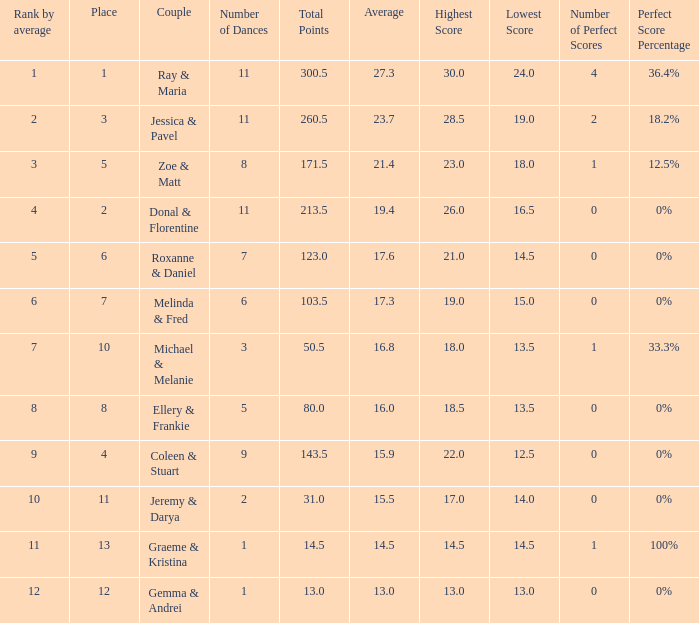If your rank by average is 9, what is the name of the couple? Coleen & Stuart. 